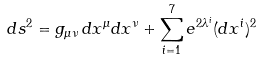<formula> <loc_0><loc_0><loc_500><loc_500>d s ^ { 2 } = g _ { \mu \nu } \, d x ^ { \mu } d x ^ { \nu } + \sum _ { i = 1 } ^ { 7 } e ^ { 2 \lambda ^ { i } } ( d x ^ { i } ) ^ { 2 }</formula> 